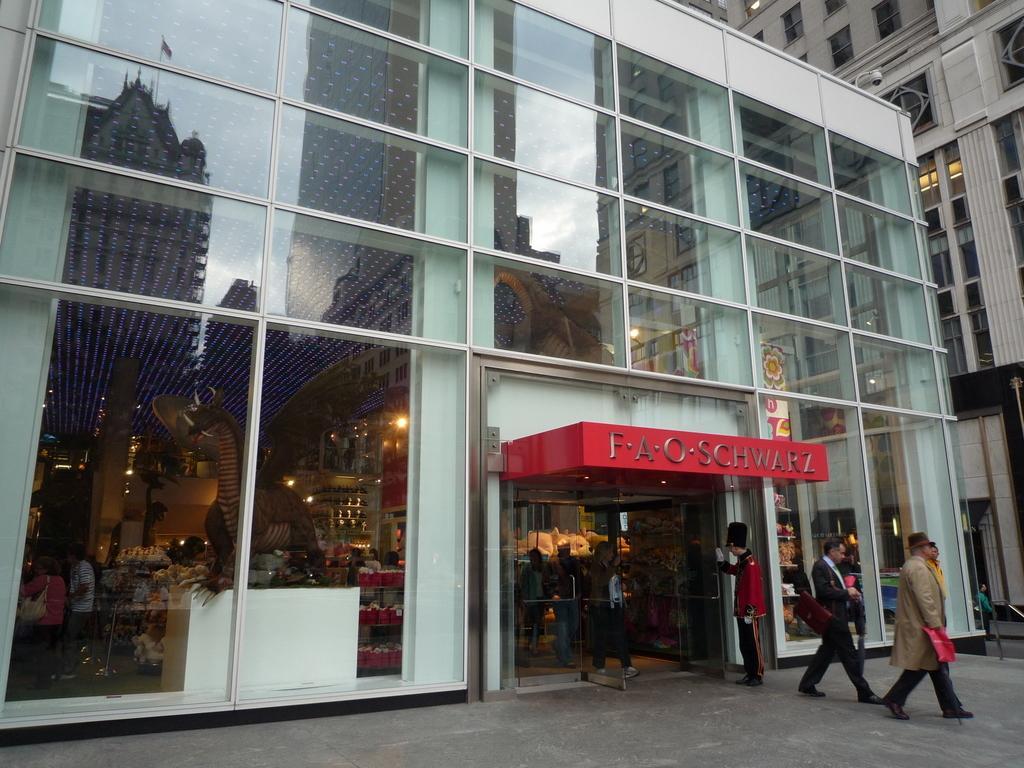In one or two sentences, can you explain what this image depicts? In this image we can see the glass building. We can also see the persons walking on the path. There is also a man standing near the entrance. We can also see the lights. On the right there is another building. 